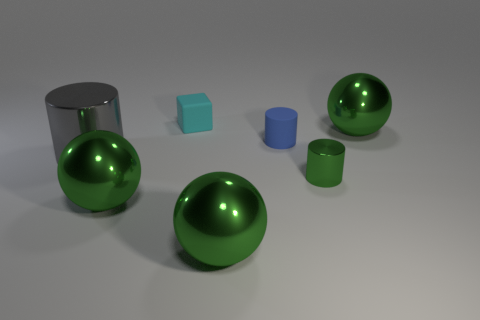Add 1 blue rubber cylinders. How many objects exist? 8 Subtract all blocks. How many objects are left? 6 Subtract 0 purple balls. How many objects are left? 7 Subtract all tiny cyan rubber blocks. Subtract all large gray metal things. How many objects are left? 5 Add 2 large gray cylinders. How many large gray cylinders are left? 3 Add 6 green things. How many green things exist? 10 